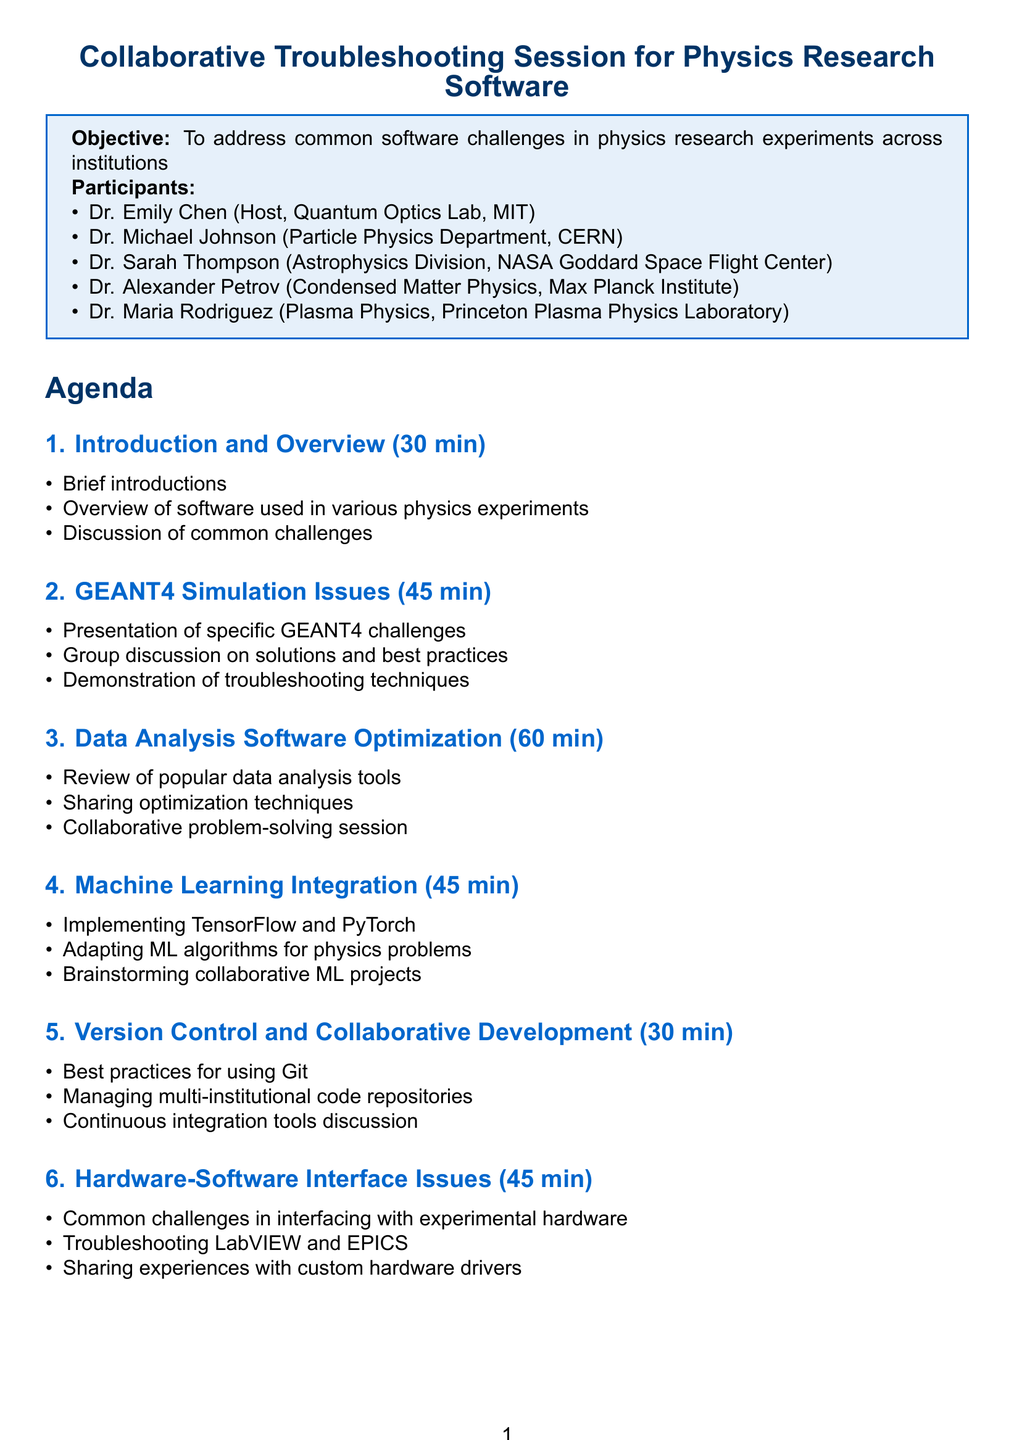What is the title of the session? The title of the session is explicitly stated at the beginning of the document as "Collaborative Troubleshooting Session for Physics Research Software."
Answer: Collaborative Troubleshooting Session for Physics Research Software Who is the host of the session? The host is identified in the participants section of the document, specifically named as Dr. Emily Chen.
Answer: Dr. Emily Chen How long is the session to troubleshoot GEANT4 simulation issues? The duration for this agenda item is specified in the document as 45 minutes, which indicates the time allotted for troubleshooting GEANT4 issues.
Answer: 45 minutes What is one of the resources needed for the session? The document lists multiple resources required, and "Video conferencing software" is mentioned as the first resource needed.
Answer: Video conferencing software How many participants are listed in the document? The document enumerates the participants, and upon review, there are a total of five individuals mentioned in the participants section.
Answer: 5 Which software tools are discussed for data analysis optimization? The document specifically mentions "ROOT" and "Python with NumPy/SciPy" as popular data analysis tools during the session on optimization.
Answer: ROOT, Python with NumPy/SciPy What is the total duration of the session's wrap-up? The document details the wrap-up session as having a specific duration of 15 minutes, indicating the time allocated for this final segment.
Answer: 15 minutes What collaborative tool is suggested for ongoing support? The document discusses the creation of a "dedicated Slack channel" for continuous support among the participants after the session.
Answer: Dedicated Slack channel 